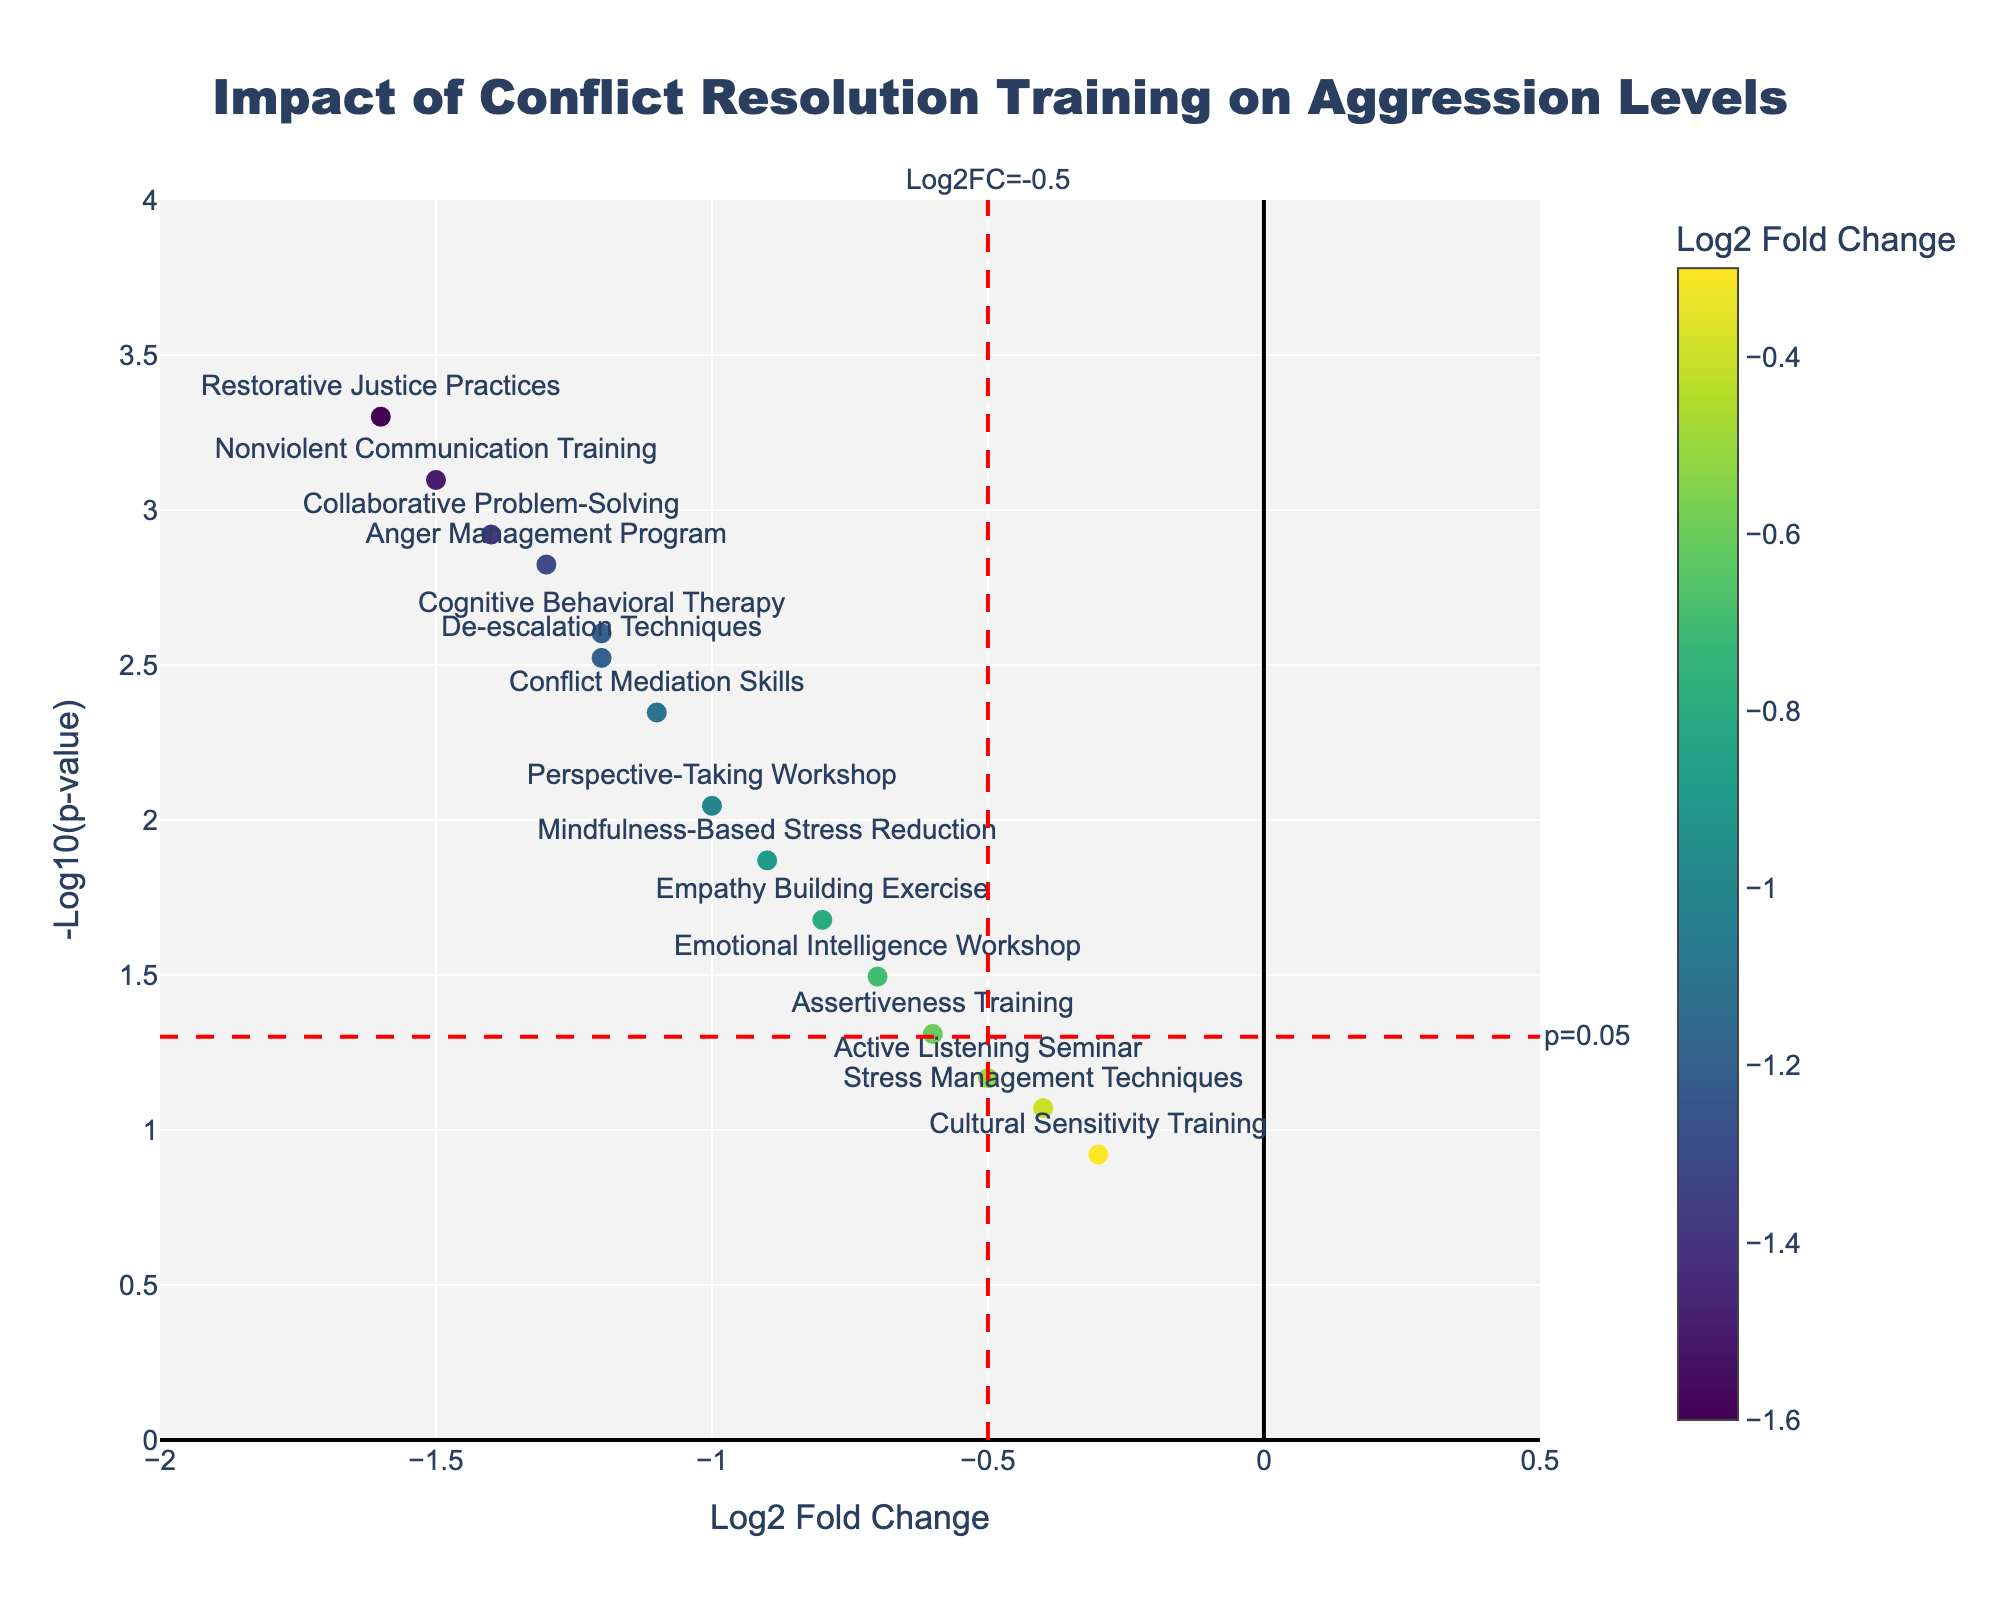What is the title of the figure? The title is usually found at the top of the figure. It provides a summary of what the plot is about. Here, it likely describes the effect of various conflict resolution training programs on aggression levels.
Answer: Impact of Conflict Resolution Training on Aggression Levels How many interventions are plotted in the figure? Count the number of data points or labels within the plot. Each marker represents one intervention.
Answer: 15 Which intervention has the highest -log10(p-value)? Locate the point with the maximum y-value on the plot, as -log10(p-value) is plotted on the y-axis.
Answer: Restorative Justice Practices Which intervention has the most significant reduction in aggression levels? Look for the intervention with the smallest log2 fold change value. The smallest value (more negative) indicates the greatest reduction in aggression level.
Answer: Restorative Justice Practices How many interventions have a p-value less than 0.05? Identify the points above the horizontal threshold line at -log10(p-value) = 1.3. Count the points above this line.
Answer: 12 Does the Cognitive Behavioral Therapy intervention have a significant effect on aggression levels (p < 0.05)? Check if the Cognitive Behavioral Therapy intervention point is above the horizontal p=0.05 line, which is at -log10(p-value) = 1.3
Answer: Yes Which intervention has both a log2 fold change less than -1 and a -log10(p-value) higher than 2? Locate the point that meets both conditions: log2 fold change less than -1 (left of x = -1) and -log10(p-value) higher than 2 (above y = 2).
Answer: Nonviolent Communication Training Which two interventions are the closest to each other on the plot? By visually comparing the distances between each pair of data points, identify the two points that are the nearest to each other.
Answer: De-escalation Techniques and Cognitive Behavioral Therapy What is the range of the x-axis and the y-axis? Observe the axes annotations. Identify the minimum and maximum values for both x and y axes.
Answer: x-axis: -2 to 0.5, y-axis: 0 to 4 